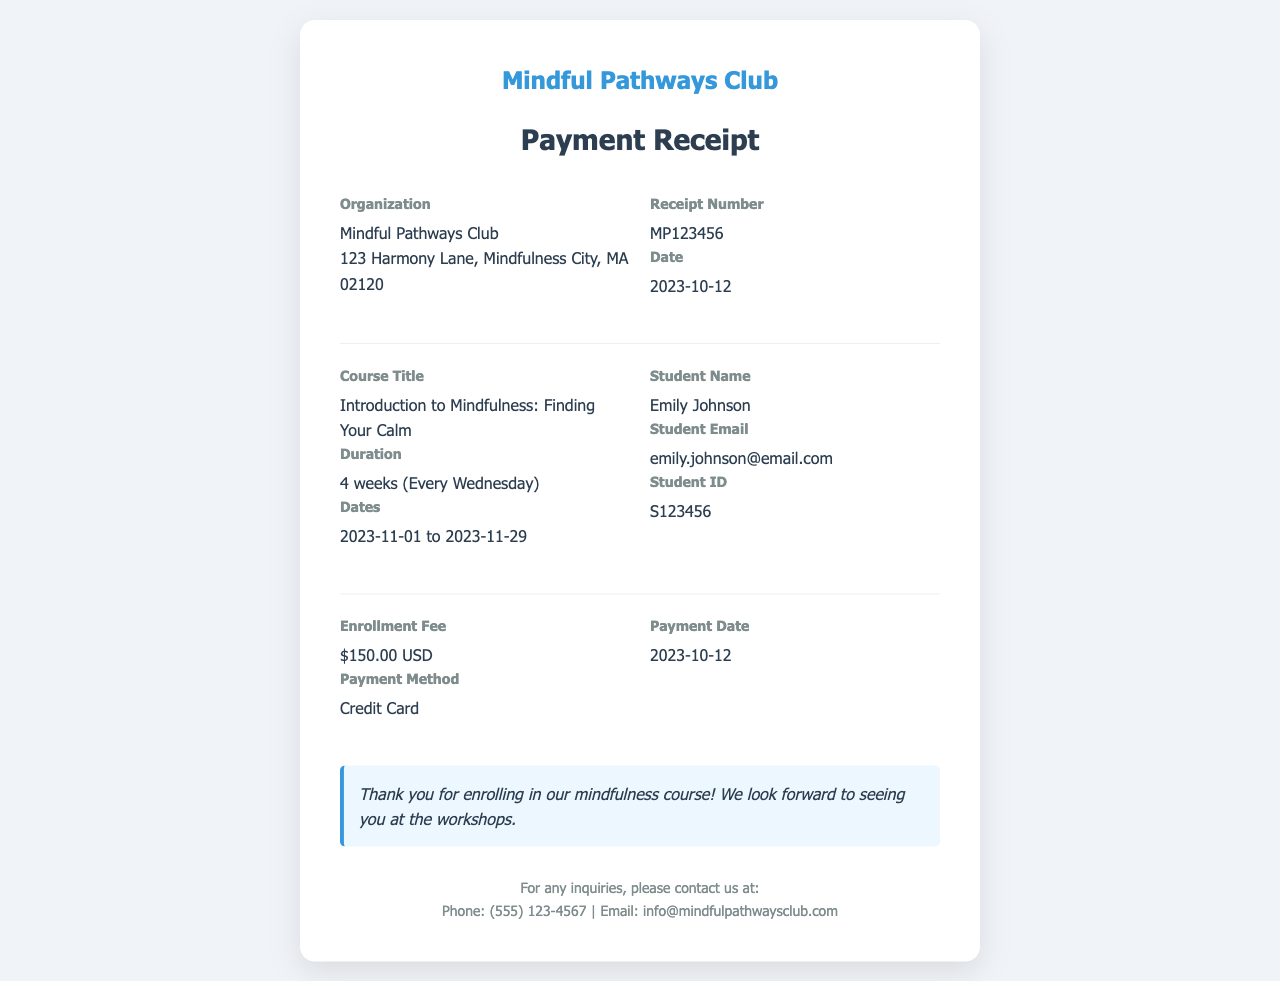What is the course title? The course title is listed under the details section of the receipt.
Answer: Introduction to Mindfulness: Finding Your Calm How long is the course duration? The duration is specified in the details section following the course title.
Answer: 4 weeks (Every Wednesday) What is the total enrollment fee? The total enrollment fee is provided in the enrollment details portion of the receipt.
Answer: $150.00 USD When does the course start? The start date is mentioned among the course details given on the receipt.
Answer: 2023-11-01 What is the receipt number? The receipt number can be found in the receipt details section.
Answer: MP123456 What method was used for payment? The payment method is noted in the enrollment fee section of the document.
Answer: Credit Card What is the student name? The student's name is listed in the personal details section of the receipt.
Answer: Emily Johnson On what date was the payment made? The payment date appears in the payment details section of the receipt.
Answer: 2023-10-12 What is the organization's name? The organization's name is at the top of the receipt, as the issuing entity.
Answer: Mindful Pathways Club 